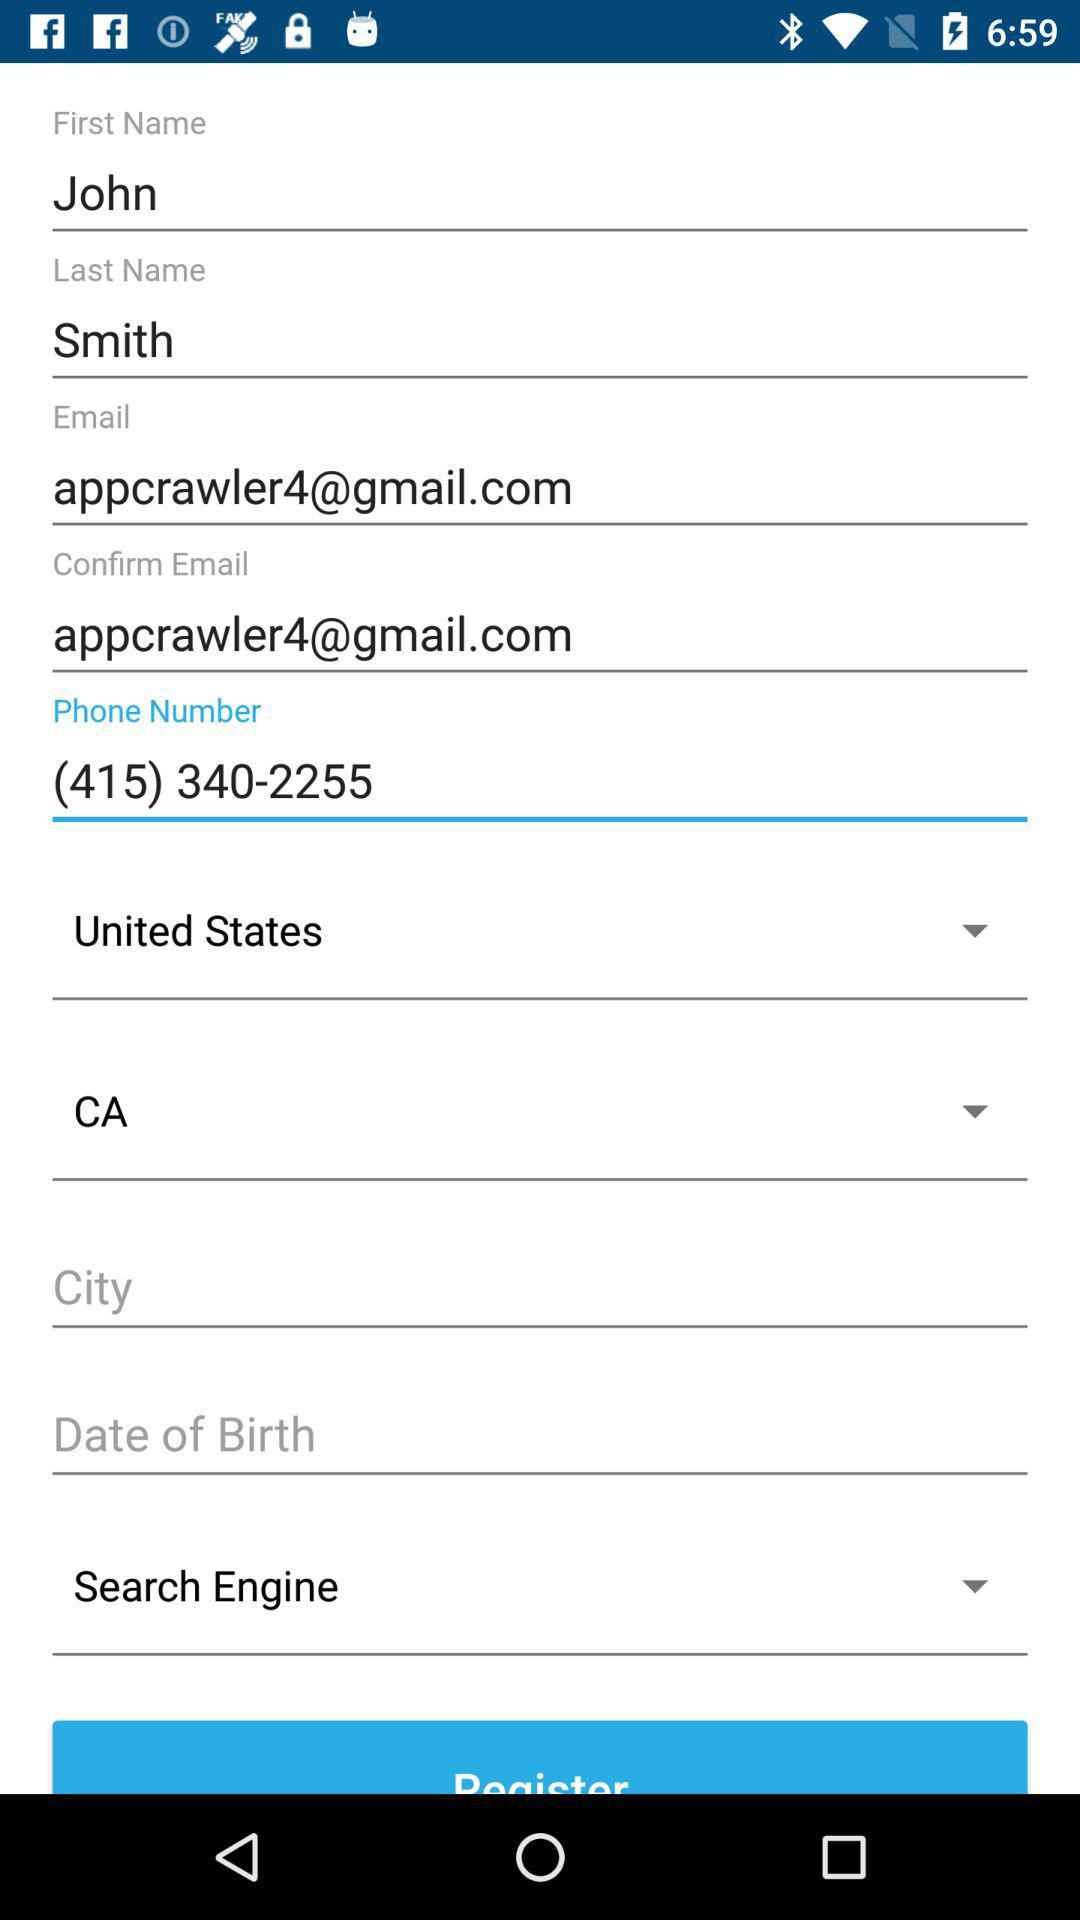What is the last name? The last name is Smith. 